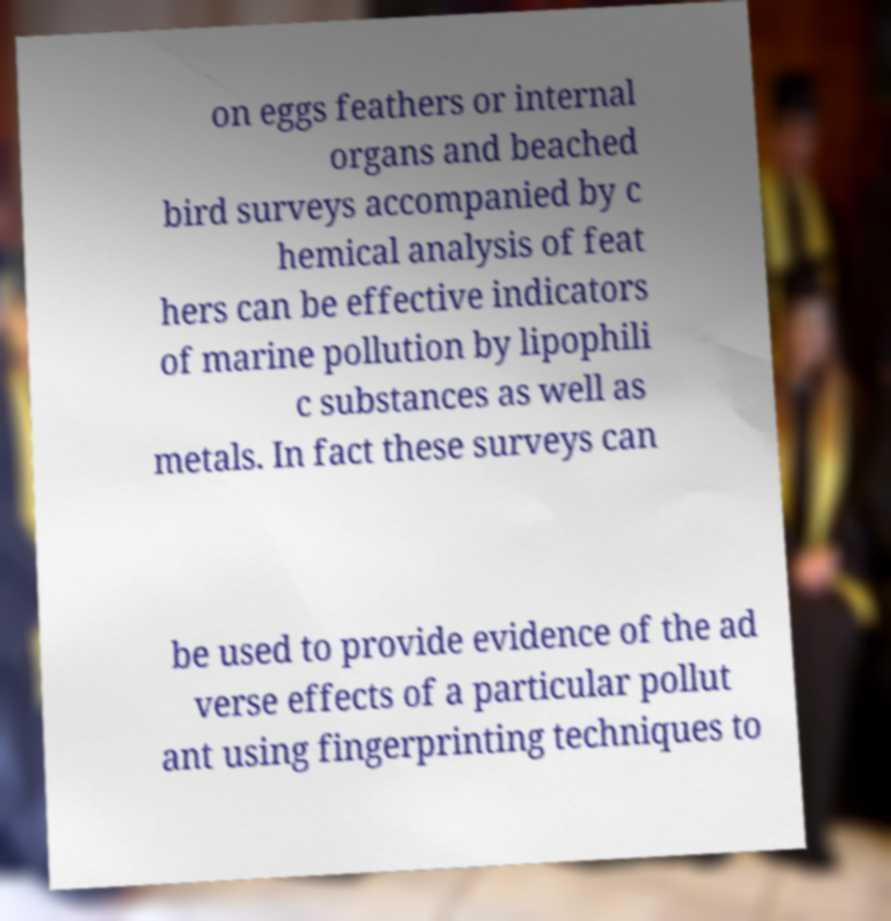Please identify and transcribe the text found in this image. on eggs feathers or internal organs and beached bird surveys accompanied by c hemical analysis of feat hers can be effective indicators of marine pollution by lipophili c substances as well as metals. In fact these surveys can be used to provide evidence of the ad verse effects of a particular pollut ant using fingerprinting techniques to 